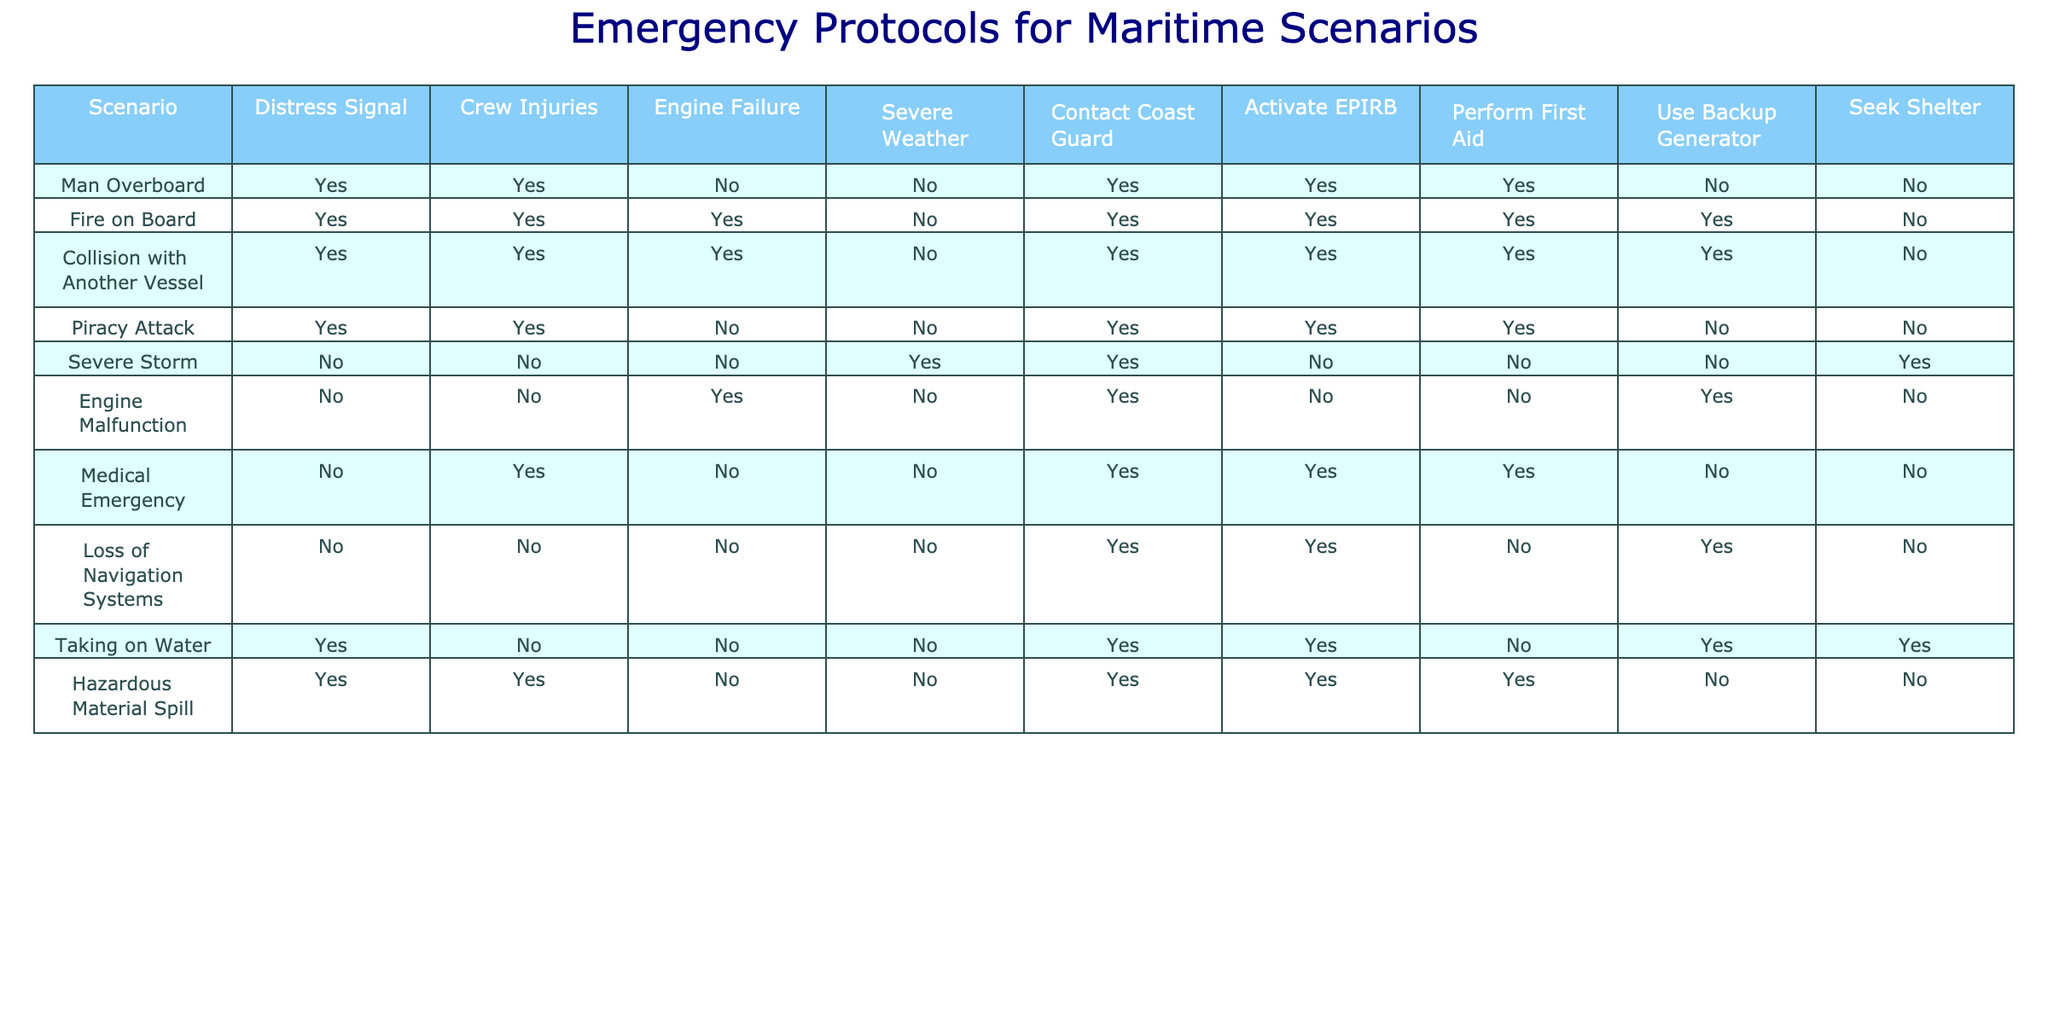What emergency protocol is activated in case of a Fire on Board? The table indicates that in the case of a Fire on Board, the protocols activated include a distress signal (Yes), contacting the Coast Guard (Yes), activating the EPIRB (Yes), performing first aid (Yes), and using a backup generator (Yes). Therefore, all these protocols are activated.
Answer: Yes, all protocols are activated Is a distress signal sent during a Medical Emergency? According to the table, the scenario of a Medical Emergency does not involve sending a distress signal (No).
Answer: No For which scenarios is first aid performed? To determine the scenarios in which first aid is performed, we look at the "Perform First Aid" column. The scenarios that show "Yes" for first aid are: Medical Emergency, Fire on Board, Collision with Another Vessel, and Hazardous Material Spill.
Answer: Medical Emergency, Fire on Board, Collision with Another Vessel, Hazardous Material Spill How many scenarios involve contacting the Coast Guard? By reviewing the "Contact Coast Guard" column in the table, we see that there are five scenarios where this is marked as "Yes": Man Overboard, Fire on Board, Collision with Another Vessel, Piracy Attack, and Medical Emergency. Thus, there are five scenarios.
Answer: 5 Is it true that during a Severe Storm, backup generators are used? The table shows that in a Severe Storm, the backup generator is not used (No).
Answer: No Which scenario is the only one that leads to seeking shelter? The table indicates that Seeking Shelter is activated only in the scenario of Severe Storm. Checking the corresponding row, it is evident that this is the only instance where Seeking Shelter (Yes) is noted.
Answer: Severe Storm In how many scenarios is the engine failure noted, and how many of them also send a distress signal? The "Engine Failure" column indicates Yes for Fire on Board, Collision with Another Vessel, and Engine Malfunction (three scenarios total). Among these, all three also send a distress signal, as indicated in the same rows' "Distress Signal" column. Thus, the answer calculations show three scenarios tied to both aspects.
Answer: 3 Considering all the scenarios, which protocol is the least activated? By reviewing the table, we see that the protocol "Use Backup Generator" is activated only in three cases: Engine Malfunction, Taking on Water, and Fire on Board. This indicates it is the least activated protocol compared to others like activating distress or contacting the Coast Guard.
Answer: Use Backup Generator 